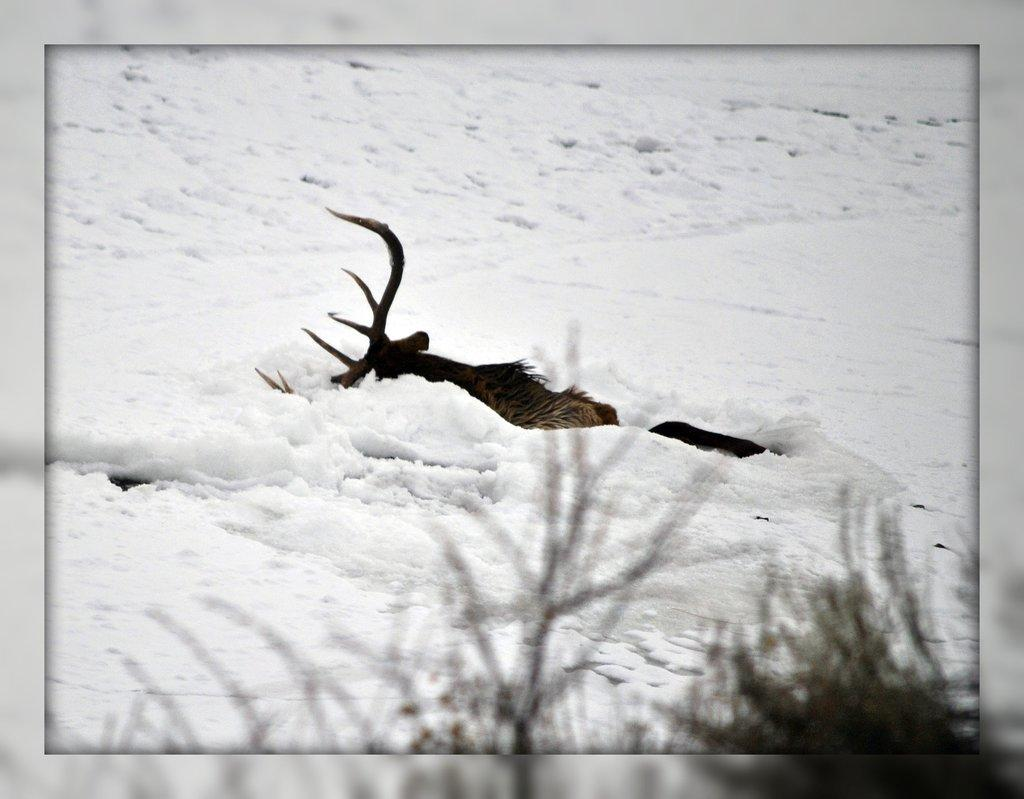What type of animal is in the image? There is an animal in the image, but its specific type cannot be determined from the provided facts. Where is the animal located in the image? The animal is in the snow in the image. What colors can be seen on the animal? The animal has black and brown coloring. What else can be seen in the image besides the animal? There are plants visible in the image. How much wealth does the bee in the image possess? There is no bee present in the image, and therefore, it cannot possess any wealth. 